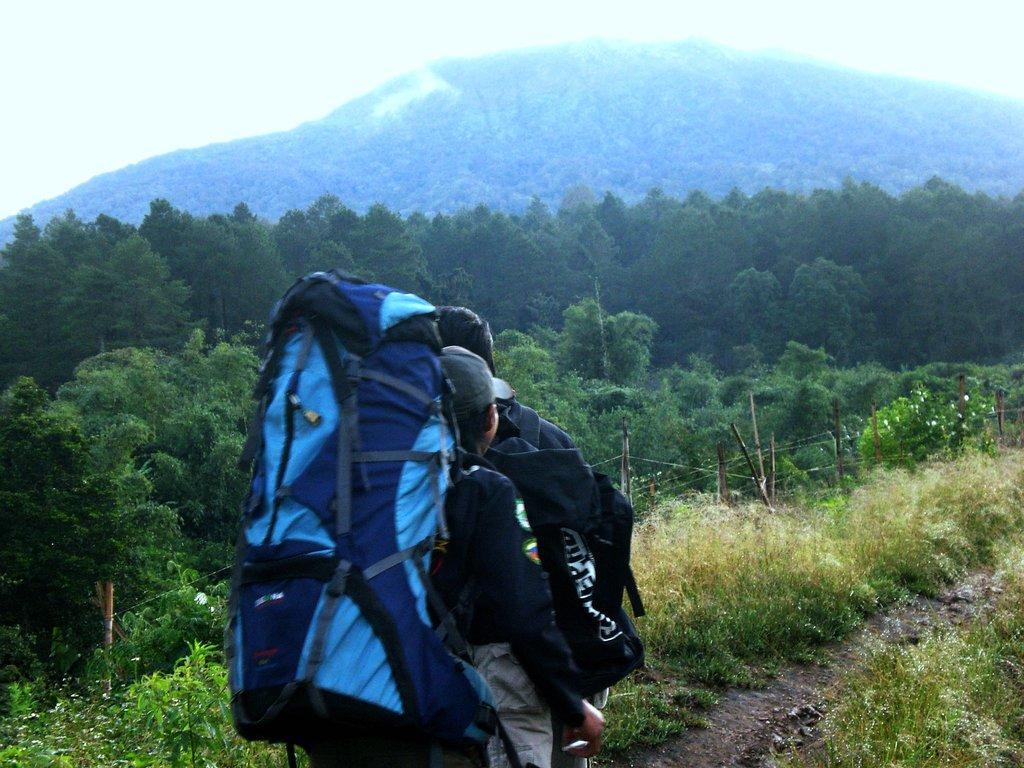Please provide a concise description of this image. In this image we can see a person wearing a bag in the foreground. In the background we can see trees, hills and fog. 